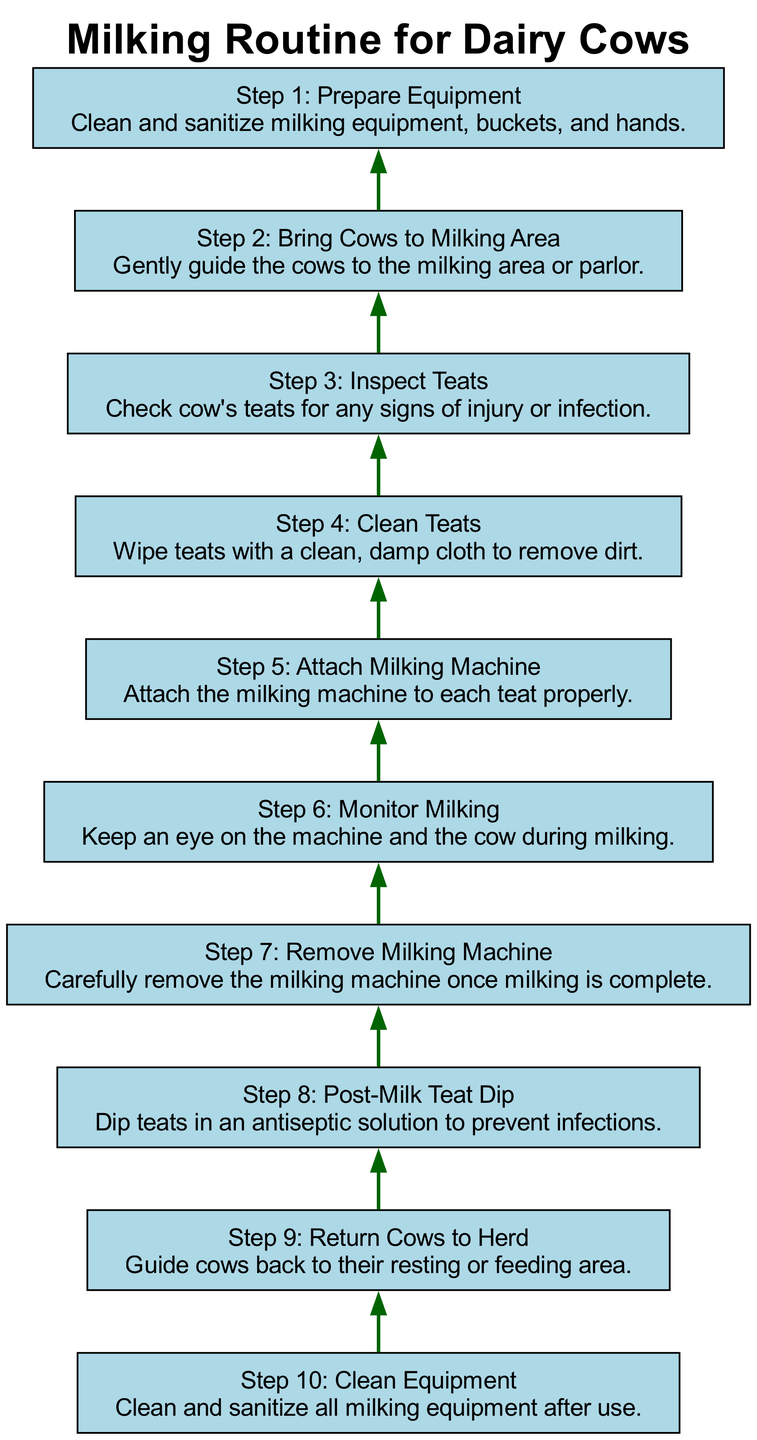What's the first step in the milking routine? The first step in the milking routine is listed at the bottom of the flow chart. It is "Step 1: Prepare Equipment" which instructs to clean and sanitize milking equipment, buckets, and hands.
Answer: Step 1: Prepare Equipment How many total steps are there in the milking routine? By counting the number of nodes in the diagram from the bottom to the top, we see that there are 10 steps listed in the flow chart.
Answer: 10 What is done before attaching the milking machine? The step before attaching the milking machine is "Clean Teats," which involves wiping teats with a clean, damp cloth to remove dirt. This is necessary for hygiene purposes.
Answer: Clean Teats What step comes after removing the milking machine? The step that follows "Remove Milking Machine" is "Post-Milk Teat Dip," where teats are dipped in an antiseptic solution to prevent infections. This implies a continuity in ensuring cow health post-milking.
Answer: Post-Milk Teat Dip What cleaning is required after milking? After milking, the last step in the flow chart is "Clean Equipment," which specifies cleaning and sanitizing all milking equipment after use. This ensures that everything is ready for the next milking session.
Answer: Clean Equipment How does one ensure cow health after milking? To ensure cow health after milking, one should perform the step "Post-Milk Teat Dip," which involves dipping teats in an antiseptic solution. This step is critical for preventing infections and maintaining the overall health of the cows.
Answer: Post-Milk Teat Dip What is the role of "Monitor Milking"? "Monitor Milking" plays the role of overseeing the process while the machine is attached, ensuring that both the cow is comfortable and the machine is functioning properly, which is crucial for smooth and safe milking.
Answer: Monitor Milking What action is taken before guiding cows back to the herd? Before guiding cows back to the herd, it is essential to perform the step "Post-Milk Teat Dip" to ensure the cows' teats are protected from potential infections before they leave the milking area.
Answer: Post-Milk Teat Dip 